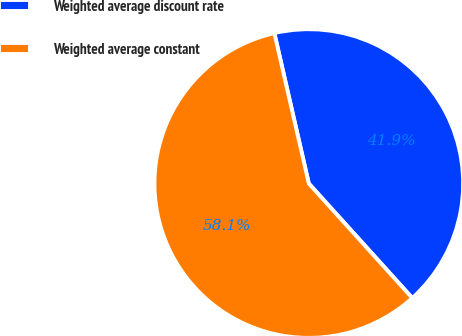Convert chart to OTSL. <chart><loc_0><loc_0><loc_500><loc_500><pie_chart><fcel>Weighted average discount rate<fcel>Weighted average constant<nl><fcel>41.89%<fcel>58.11%<nl></chart> 